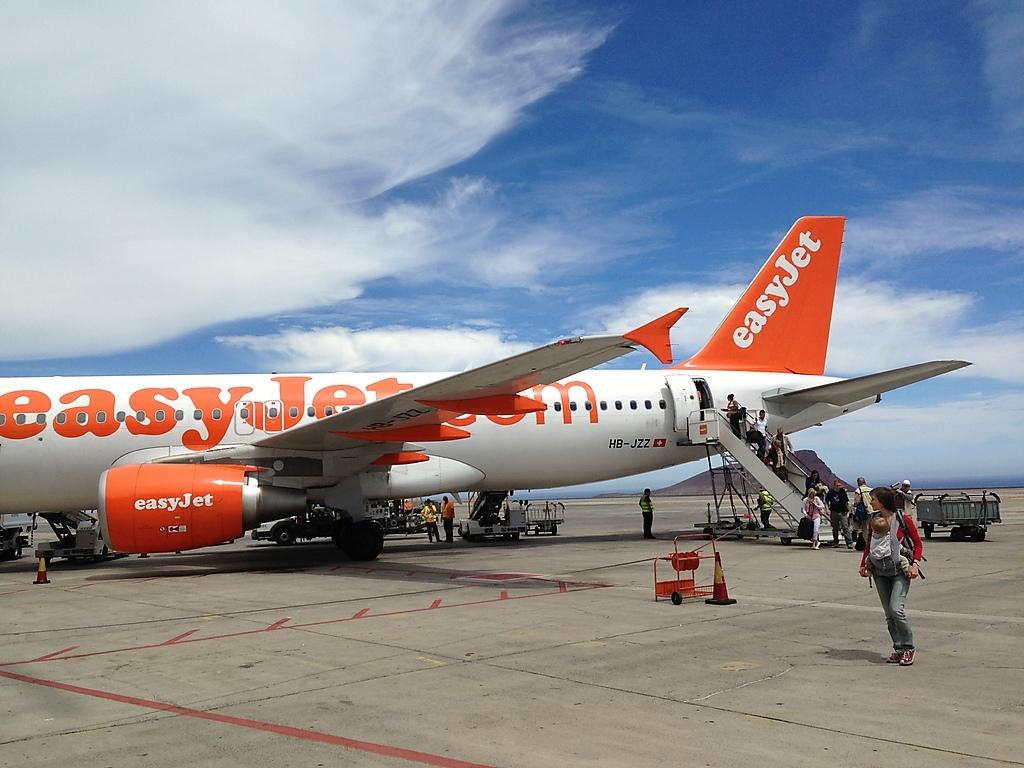<image>
Relay a brief, clear account of the picture shown. a white and orange easy jet sitting on a runway while being boarded. 